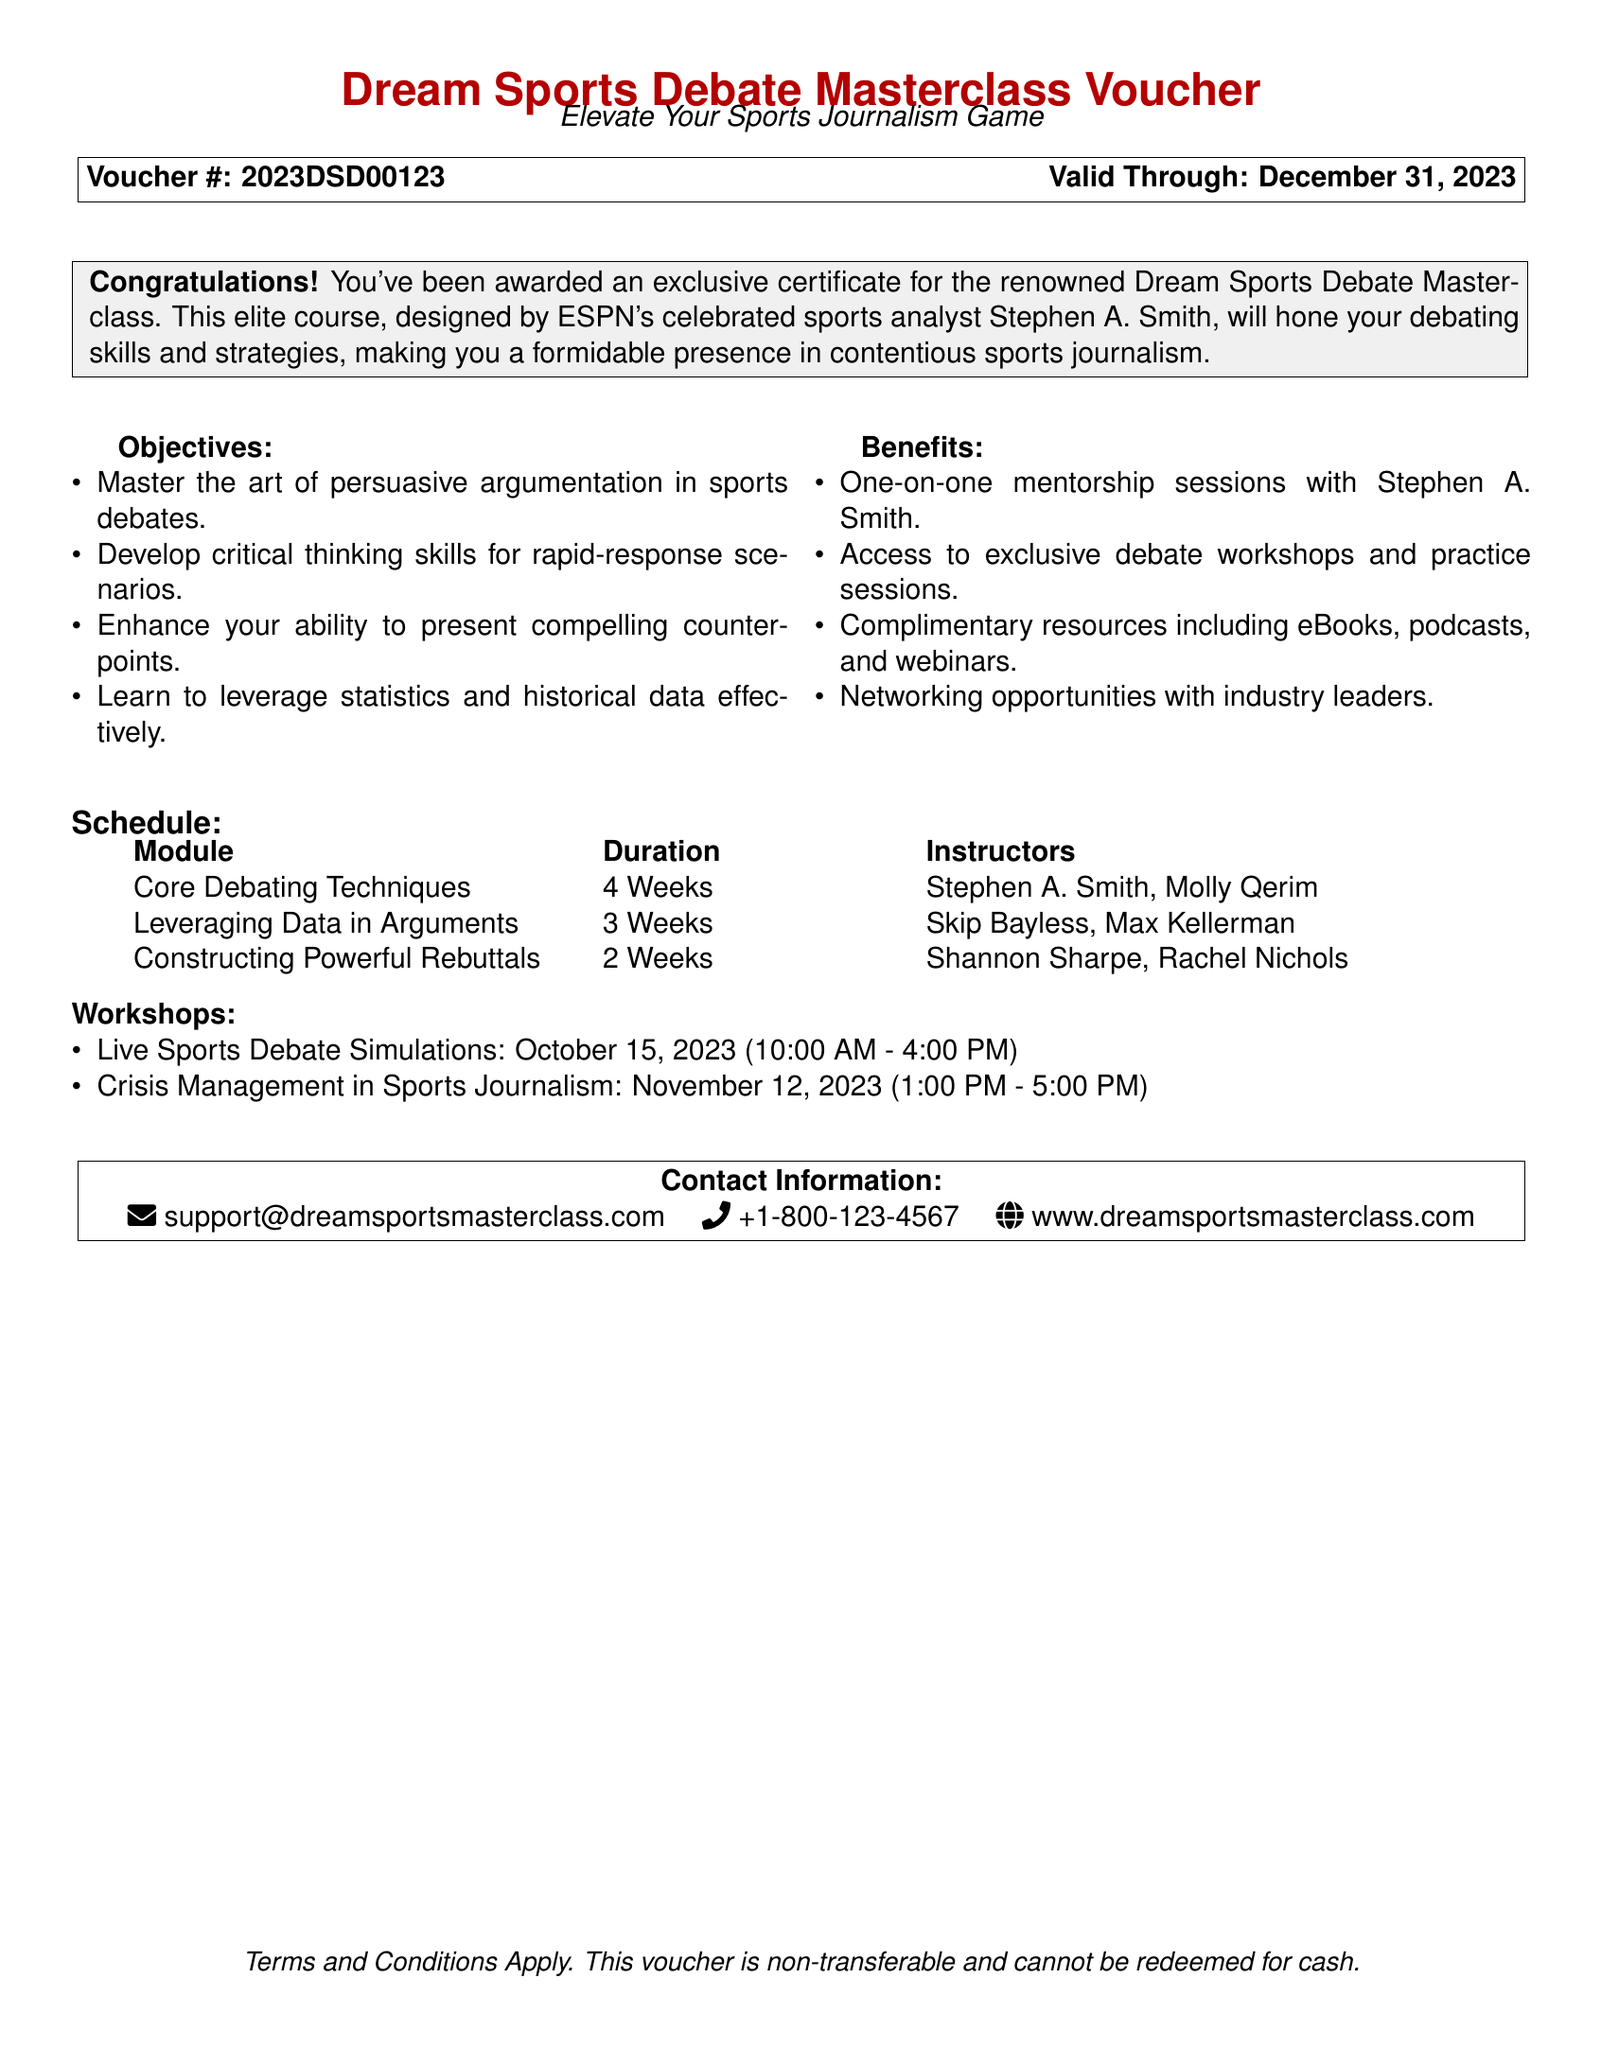What is the voucher number? The voucher number is indicated in the document as Voucher #: 2023DSD00123.
Answer: 2023DSD00123 Who designed the masterclass? The masterclass is designed by ESPN's celebrated sports analyst Stephen A. Smith.
Answer: Stephen A. Smith What is the duration of the "Core Debating Techniques" module? The duration of the "Core Debating Techniques" module is specified in the table as 4 weeks.
Answer: 4 Weeks What type of mentorship is offered in the masterclass? The document states that there are one-on-one mentorship sessions as part of the course.
Answer: One-on-one mentorship sessions When is the live sports debate simulation workshop scheduled? The document specifies the date of the live sports debate simulation workshop as October 15, 2023.
Answer: October 15, 2023 What is one benefit of the masterclass? The benefits listed include access to exclusive debate workshops and practice sessions.
Answer: Access to exclusive debate workshops What is the valid expiration date of the voucher? The valid expiration date of the voucher is indicated in the document as December 31, 2023.
Answer: December 31, 2023 How many weeks is the "Leveraging Data in Arguments" module? The document provides the duration of the module as 3 weeks.
Answer: 3 Weeks 